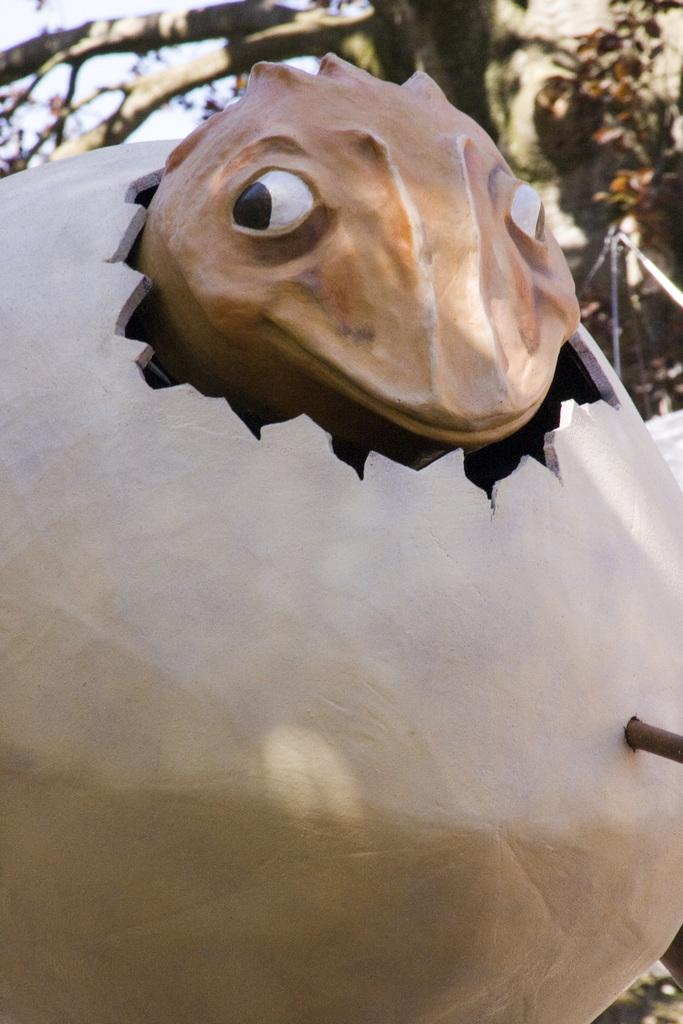What is the main subject of the image? The main subject of the image is a sculpture of a dragon egg. What is unique about the sculpture? The sculpture contains a dragon inside the egg. What can be seen in the background of the image? There is a tree in the background of the image. What type of fowl can be seen perched on the dragon egg in the image? There is no fowl present on the dragon egg in the image. 